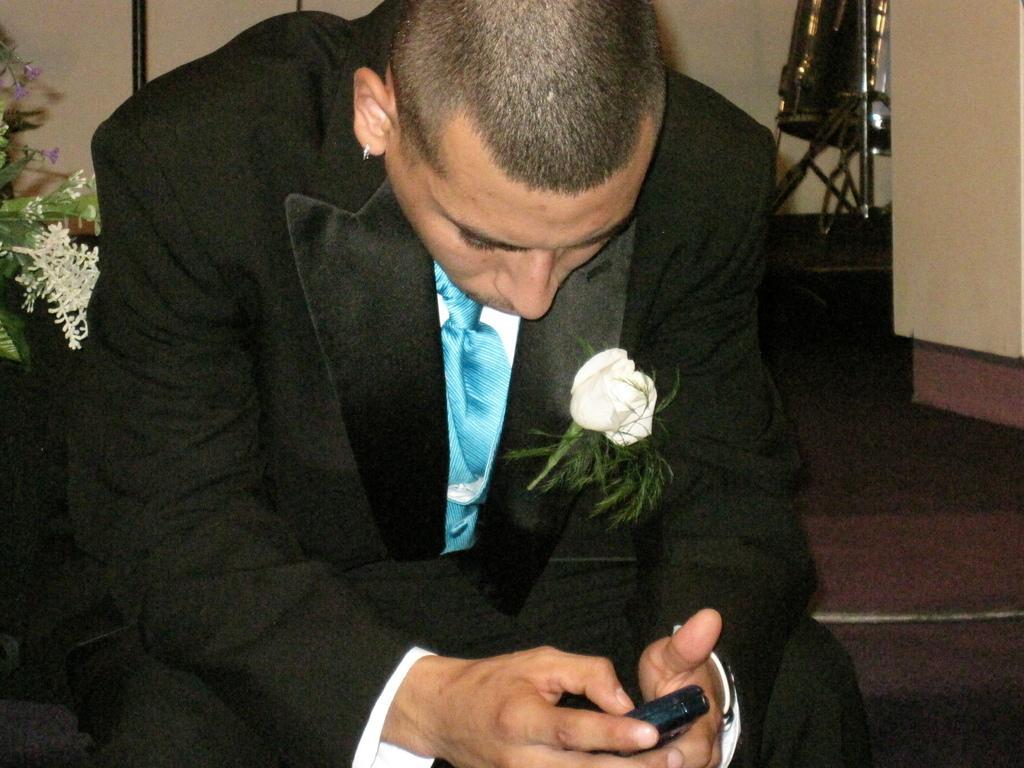Describe this image in one or two sentences. Here I can see a man holding a mobile in the hand, sitting and looking into the mobile. On the left side there is a plant along with the flowers. In the background there is a wall and also there is a metal object placed on the floor. 